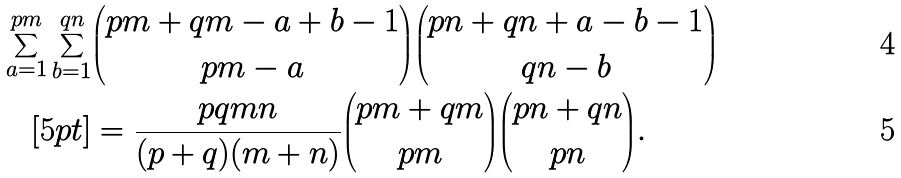<formula> <loc_0><loc_0><loc_500><loc_500>\sum _ { a = 1 } ^ { p m } \sum _ { b = 1 } ^ { q n } & { p m + q m - a + b - 1 \choose p m - a } { p n + q n + a - b - 1 \choose q n - b } \\ [ 5 p t ] & = \frac { p q m n } { ( p + q ) ( m + n ) } { p m + q m \choose p m } { p n + q n \choose p n } .</formula> 